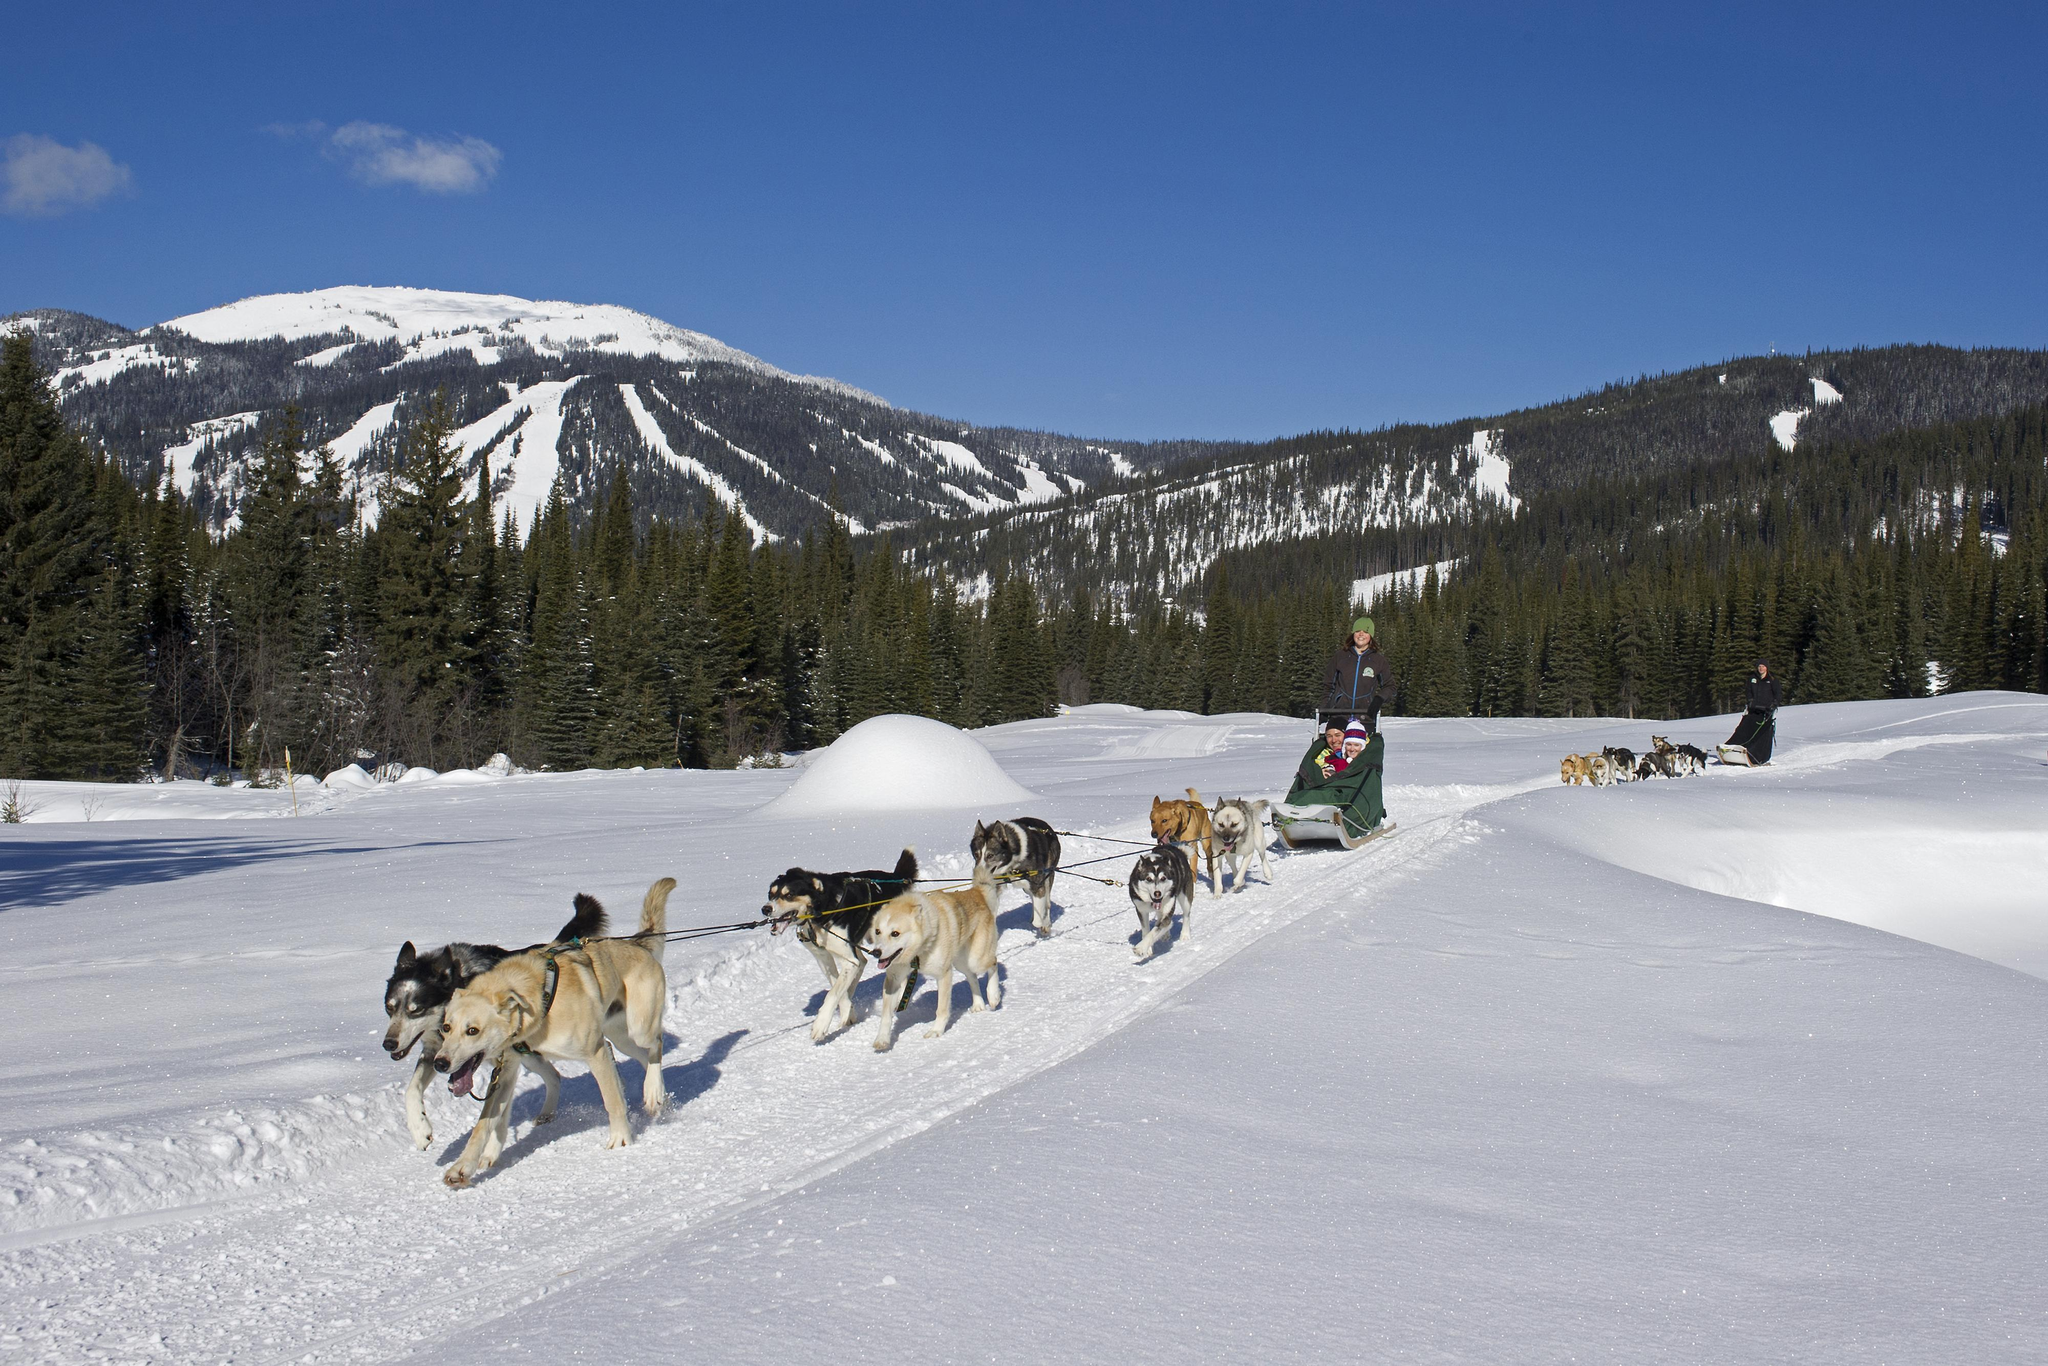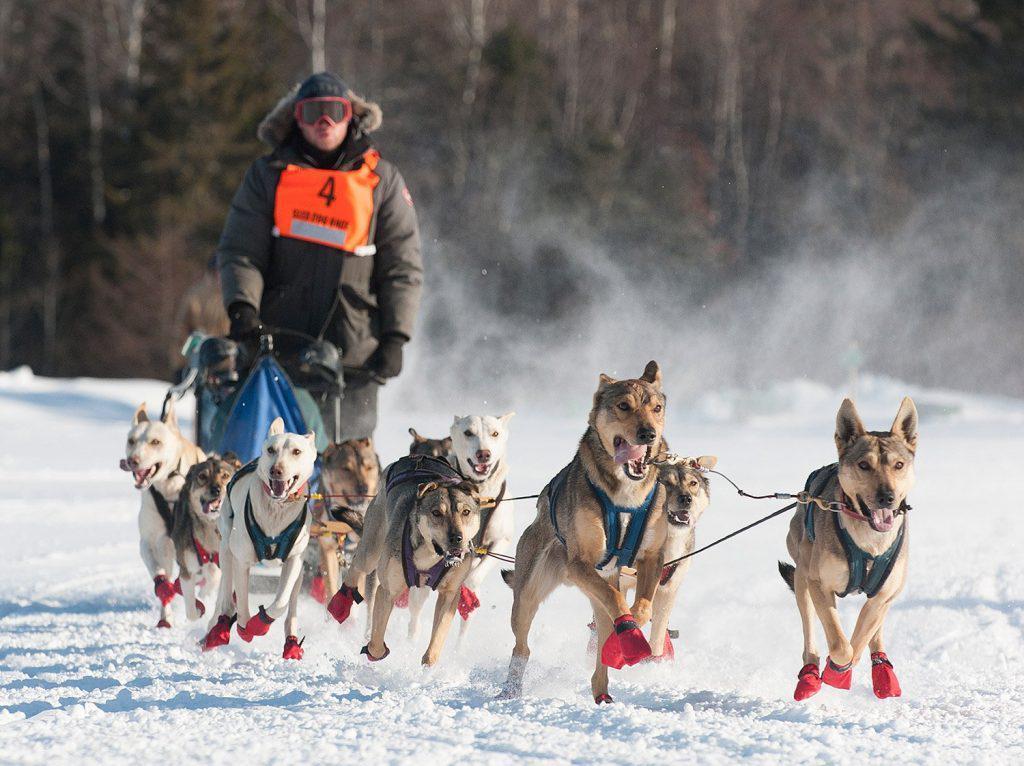The first image is the image on the left, the second image is the image on the right. Examine the images to the left and right. Is the description "The combined images contain three teams of sled dogs running forward across the snow instead of away from the camera." accurate? Answer yes or no. Yes. The first image is the image on the left, the second image is the image on the right. Analyze the images presented: Is the assertion "Both images show at least one sled pulled by no more than five dogs." valid? Answer yes or no. No. 